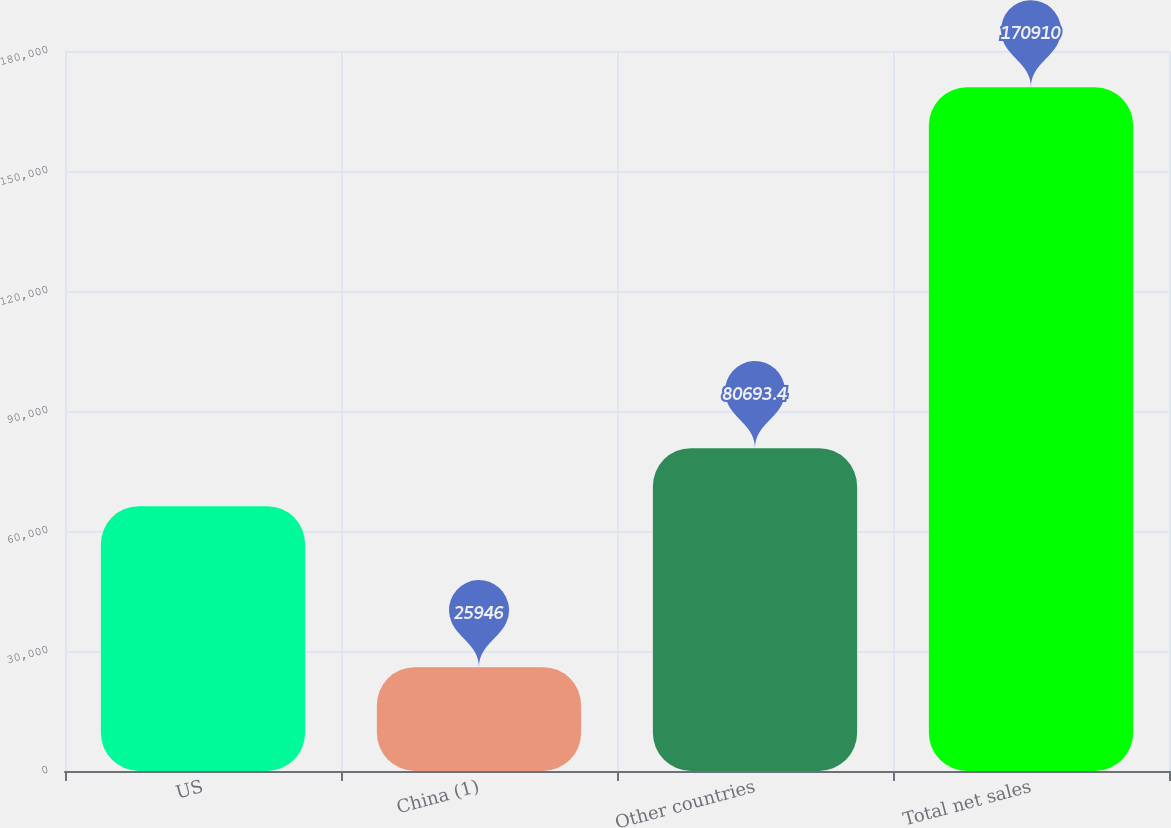Convert chart to OTSL. <chart><loc_0><loc_0><loc_500><loc_500><bar_chart><fcel>US<fcel>China (1)<fcel>Other countries<fcel>Total net sales<nl><fcel>66197<fcel>25946<fcel>80693.4<fcel>170910<nl></chart> 